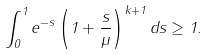<formula> <loc_0><loc_0><loc_500><loc_500>\int _ { 0 } ^ { 1 } e ^ { - s } \left ( 1 + \frac { s } { \mu } \right ) ^ { k + 1 } d s \geq 1 .</formula> 